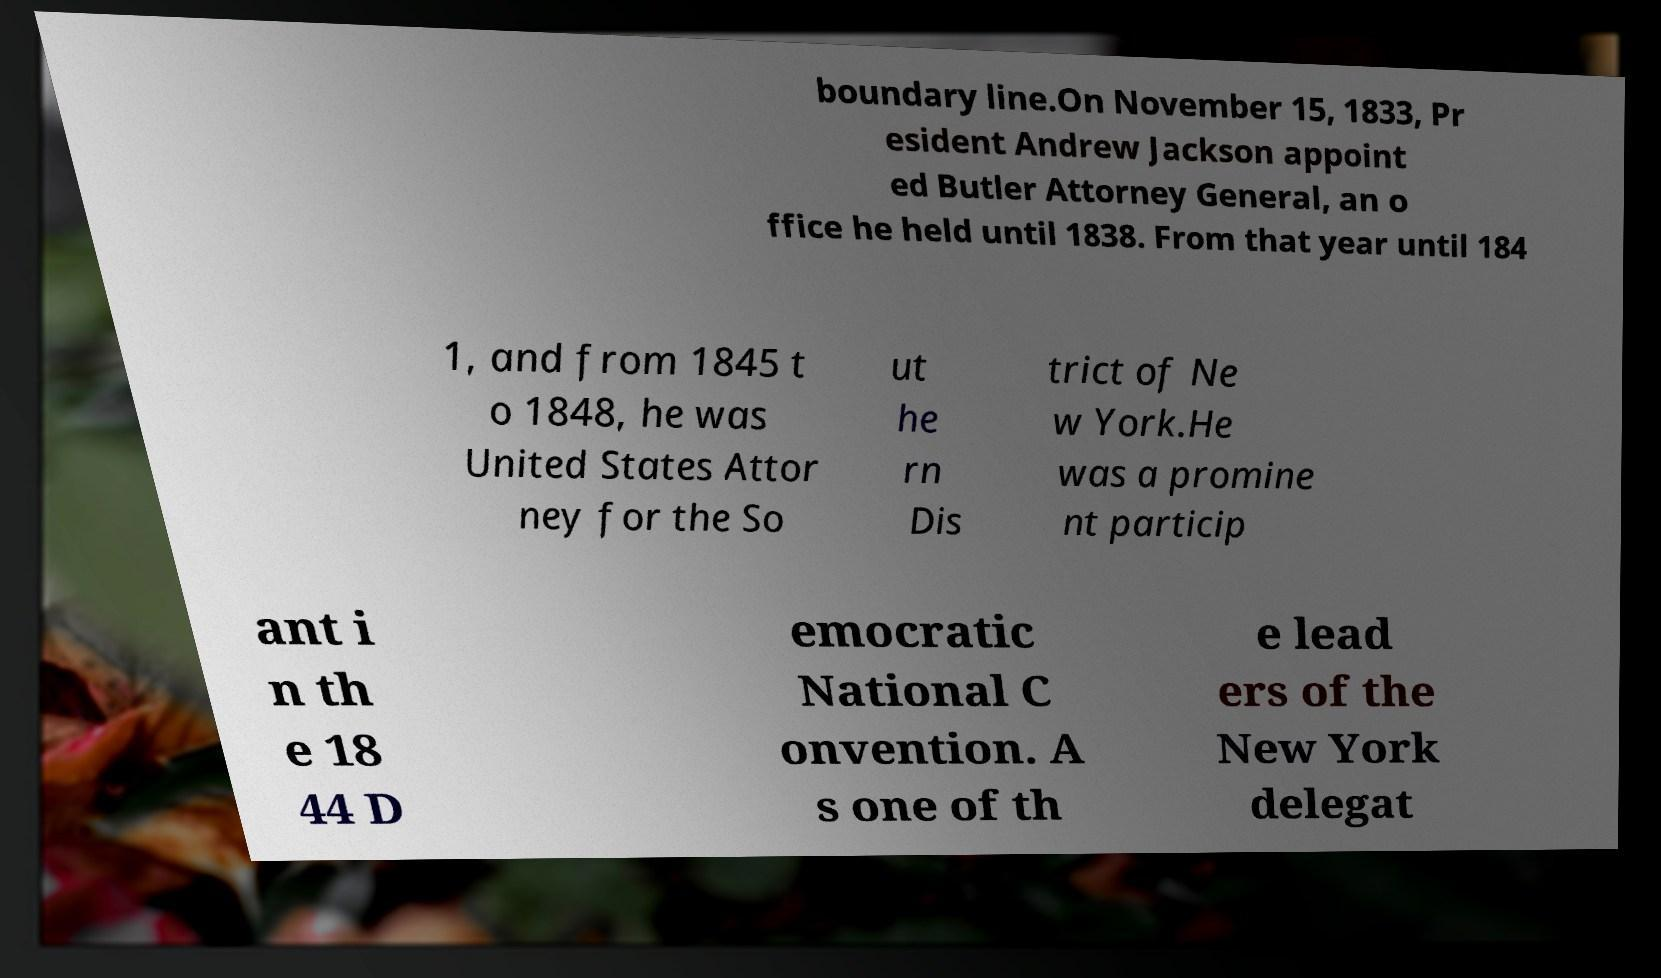Could you assist in decoding the text presented in this image and type it out clearly? boundary line.On November 15, 1833, Pr esident Andrew Jackson appoint ed Butler Attorney General, an o ffice he held until 1838. From that year until 184 1, and from 1845 t o 1848, he was United States Attor ney for the So ut he rn Dis trict of Ne w York.He was a promine nt particip ant i n th e 18 44 D emocratic National C onvention. A s one of th e lead ers of the New York delegat 